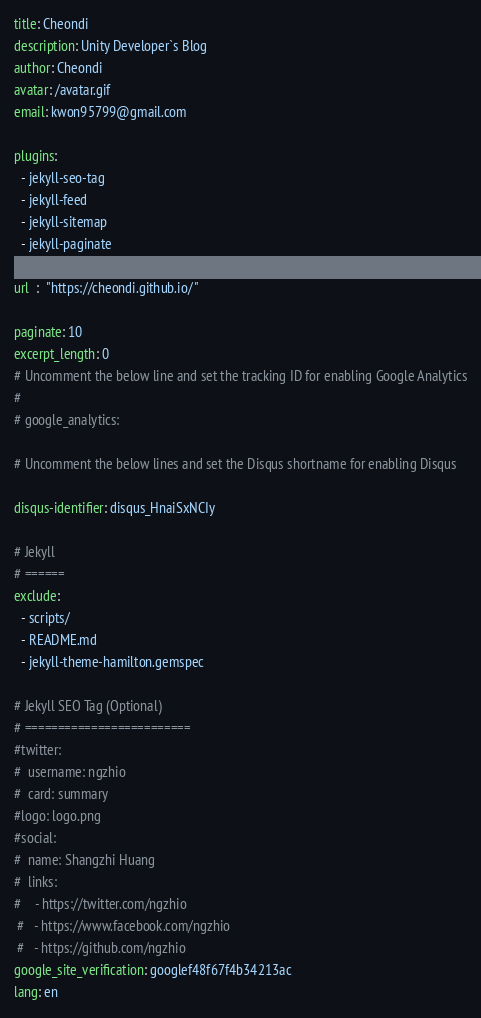<code> <loc_0><loc_0><loc_500><loc_500><_YAML_>title: Cheondi
description: Unity Developer`s Blog
author: Cheondi
avatar: /avatar.gif
email: kwon95799@gmail.com

plugins:
  - jekyll-seo-tag
  - jekyll-feed
  - jekyll-sitemap
  - jekyll-paginate

url  :  "https://cheondi.github.io/"

paginate: 10
excerpt_length: 0
# Uncomment the below line and set the tracking ID for enabling Google Analytics
# 
# google_analytics: 

# Uncomment the below lines and set the Disqus shortname for enabling Disqus
 
disqus-identifier: disqus_HnaiSxNCIy

# Jekyll
# ======
exclude:
  - scripts/
  - README.md
  - jekyll-theme-hamilton.gemspec

# Jekyll SEO Tag (Optional)
# =========================
#twitter:
#  username: ngzhio
#  card: summary
#logo: logo.png
#social:
#  name: Shangzhi Huang
#  links:
#    - https://twitter.com/ngzhio
 #   - https://www.facebook.com/ngzhio
 #   - https://github.com/ngzhio
google_site_verification: googlef48f67f4b34213ac
lang: en
</code> 